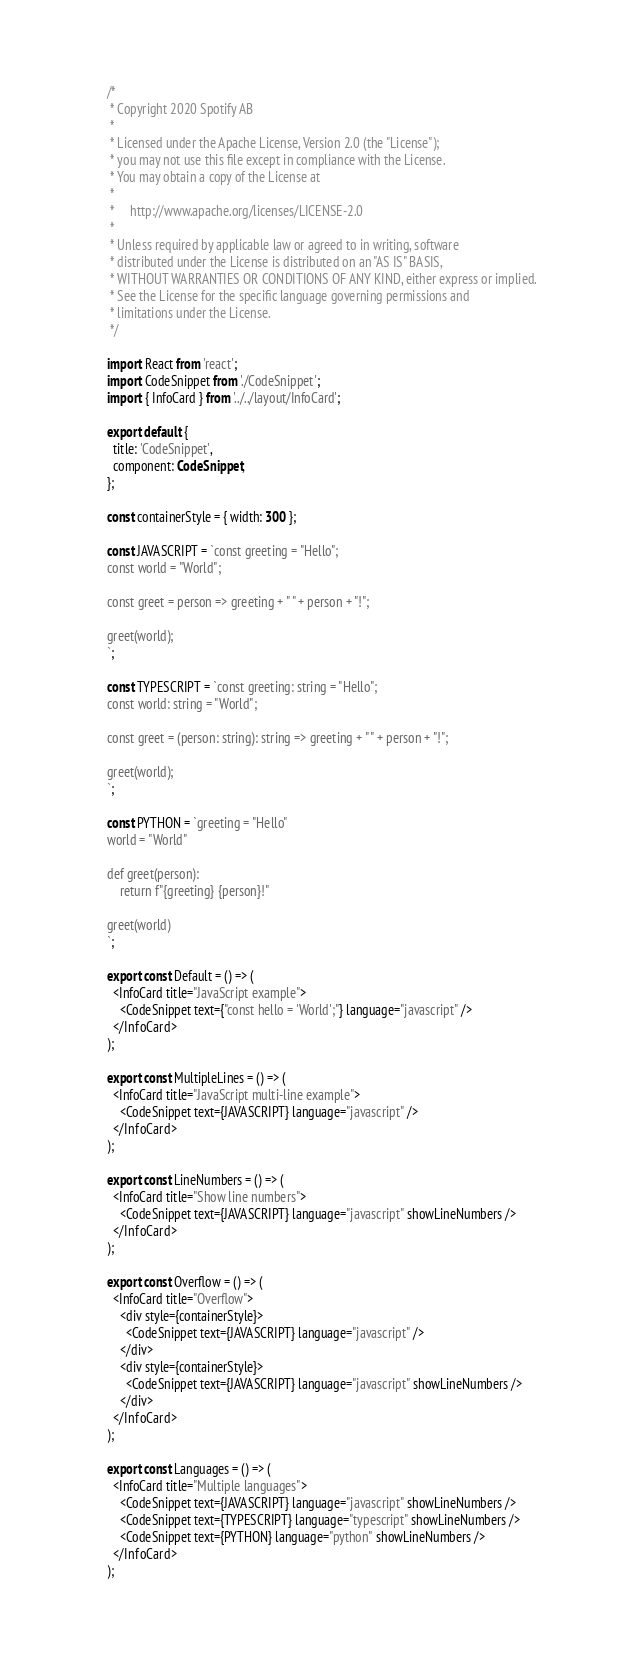Convert code to text. <code><loc_0><loc_0><loc_500><loc_500><_TypeScript_>/*
 * Copyright 2020 Spotify AB
 *
 * Licensed under the Apache License, Version 2.0 (the "License");
 * you may not use this file except in compliance with the License.
 * You may obtain a copy of the License at
 *
 *     http://www.apache.org/licenses/LICENSE-2.0
 *
 * Unless required by applicable law or agreed to in writing, software
 * distributed under the License is distributed on an "AS IS" BASIS,
 * WITHOUT WARRANTIES OR CONDITIONS OF ANY KIND, either express or implied.
 * See the License for the specific language governing permissions and
 * limitations under the License.
 */

import React from 'react';
import CodeSnippet from './CodeSnippet';
import { InfoCard } from '../../layout/InfoCard';

export default {
  title: 'CodeSnippet',
  component: CodeSnippet,
};

const containerStyle = { width: 300 };

const JAVASCRIPT = `const greeting = "Hello";
const world = "World";

const greet = person => greeting + " " + person + "!";

greet(world);
`;

const TYPESCRIPT = `const greeting: string = "Hello";
const world: string = "World";

const greet = (person: string): string => greeting + " " + person + "!";

greet(world);
`;

const PYTHON = `greeting = "Hello"
world = "World"

def greet(person):
    return f"{greeting} {person}!"

greet(world)
`;

export const Default = () => (
  <InfoCard title="JavaScript example">
    <CodeSnippet text={"const hello = 'World';"} language="javascript" />
  </InfoCard>
);

export const MultipleLines = () => (
  <InfoCard title="JavaScript multi-line example">
    <CodeSnippet text={JAVASCRIPT} language="javascript" />
  </InfoCard>
);

export const LineNumbers = () => (
  <InfoCard title="Show line numbers">
    <CodeSnippet text={JAVASCRIPT} language="javascript" showLineNumbers />
  </InfoCard>
);

export const Overflow = () => (
  <InfoCard title="Overflow">
    <div style={containerStyle}>
      <CodeSnippet text={JAVASCRIPT} language="javascript" />
    </div>
    <div style={containerStyle}>
      <CodeSnippet text={JAVASCRIPT} language="javascript" showLineNumbers />
    </div>
  </InfoCard>
);

export const Languages = () => (
  <InfoCard title="Multiple languages">
    <CodeSnippet text={JAVASCRIPT} language="javascript" showLineNumbers />
    <CodeSnippet text={TYPESCRIPT} language="typescript" showLineNumbers />
    <CodeSnippet text={PYTHON} language="python" showLineNumbers />
  </InfoCard>
);
</code> 